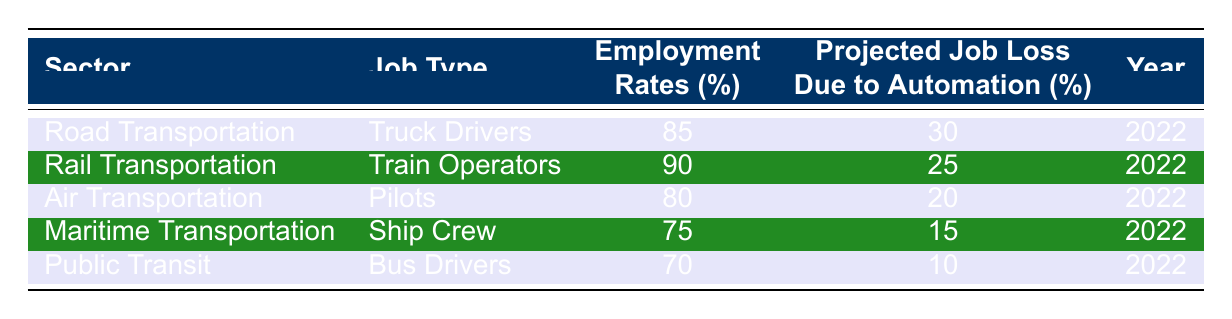What is the employment rate for truck drivers in road transportation? The table shows the employment rates for various job types. Looking at the "Road Transportation" sector and the "Truck Drivers" job type, the employment rate is 85%.
Answer: 85% Which transportation sector has the highest employment rate? By comparing the employment rates listed for each sector, we see that "Rail Transportation" has the highest rate at 90%.
Answer: 90% What is the projected job loss due to automation for pilots? We can find the job type "Pilots" under "Air Transportation" in the table; the projected job loss due to automation is stated as 20%.
Answer: 20% If we consider the job losses due to automation, which group of workers is least affected? We can compare the "Projected Job Loss Due to Automation (%)" for all job types. "Bus Drivers" in the "Public Transit" sector has the lowest percentage at 10%, indicating they are least affected.
Answer: 10% What are the employment rates for maritime and public transit workers? The table provides the employment rates for "Ship Crew" in "Maritime Transportation" (75%) and "Bus Drivers" in "Public Transit" (70%). This gives us two employment rates to compare.
Answer: 75% and 70% Calculate the average projected job loss due to automation across all sectors. To find the average, we add the projected job losses: 30 + 25 + 20 + 15 + 10 = 100. Then we divide by the number of sectors (5): 100 / 5 = 20.
Answer: 20% Is it true that air transportation has a higher employment rate than maritime transportation? By comparing the employment rates for "Air Transportation" (80%) and "Maritime Transportation" (75%), it is clear that the employment rate in air transportation is indeed higher.
Answer: Yes Which sector is projected to have the highest job loss due to automation and what is that rate? Looking at the "Projected Job Loss Due to Automation (%)", "Road Transportation" has the highest at 30%, compared to other sectors.
Answer: Road Transportation, 30% What is the difference in employment rates between train operators and bus drivers? The employment rate for "Train Operators" is 90% and for "Bus Drivers" it is 70%. The difference is calculated as 90 - 70 = 20%.
Answer: 20% For which job type is the projected job loss due to automation the lowest? Checking the "Projected Job Loss Due to Automation (%)", the lowest percentage belongs to "Bus Drivers" at 10%.
Answer: Bus Drivers 